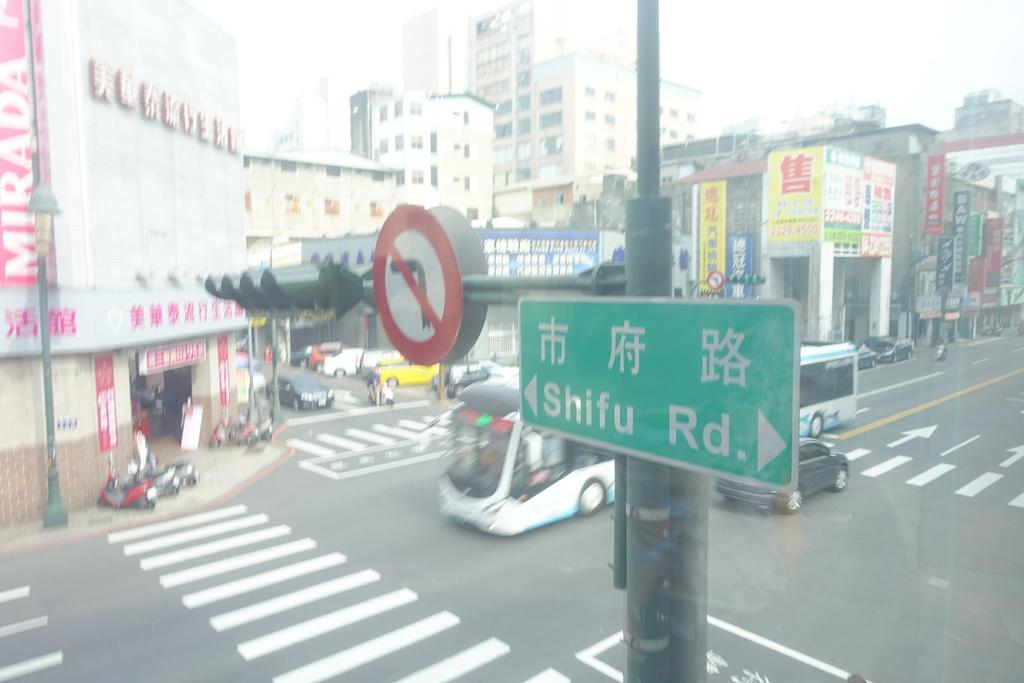What is the name of the road in the photo?
Keep it short and to the point. Shifu rd. What is the name of the store on the left?
Offer a very short reply. Mirada. 